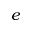<formula> <loc_0><loc_0><loc_500><loc_500>e</formula> 